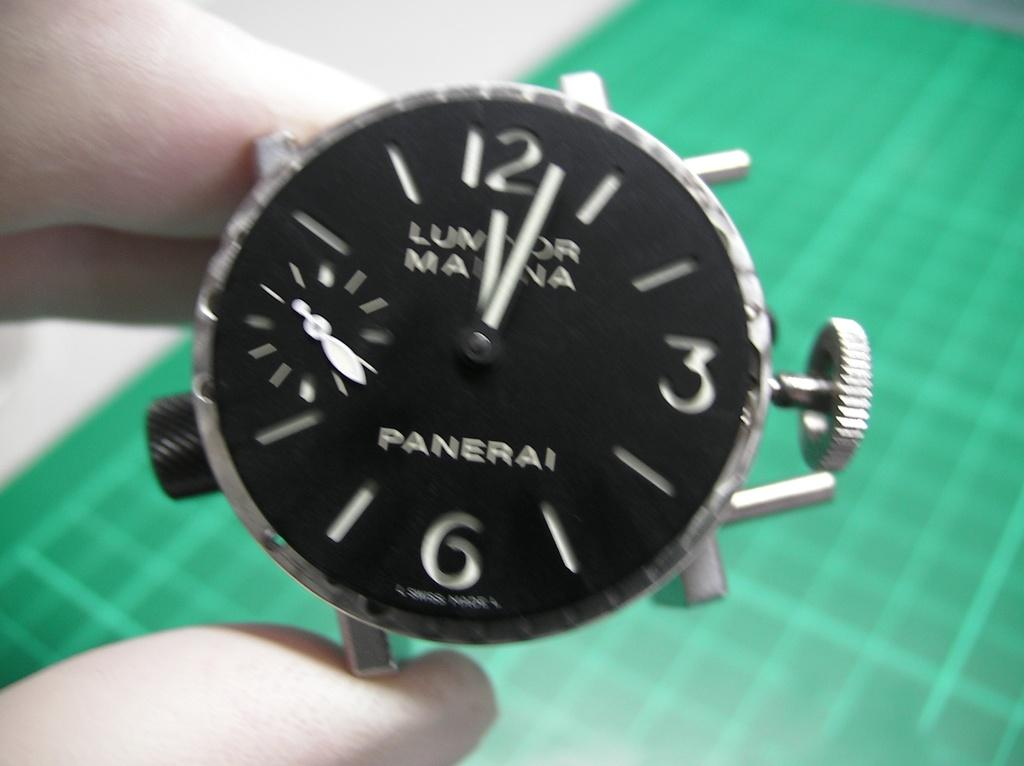<image>
Create a compact narrative representing the image presented. Silver watch with black face and white numbers says PANERAI in the middle at the bottom. 